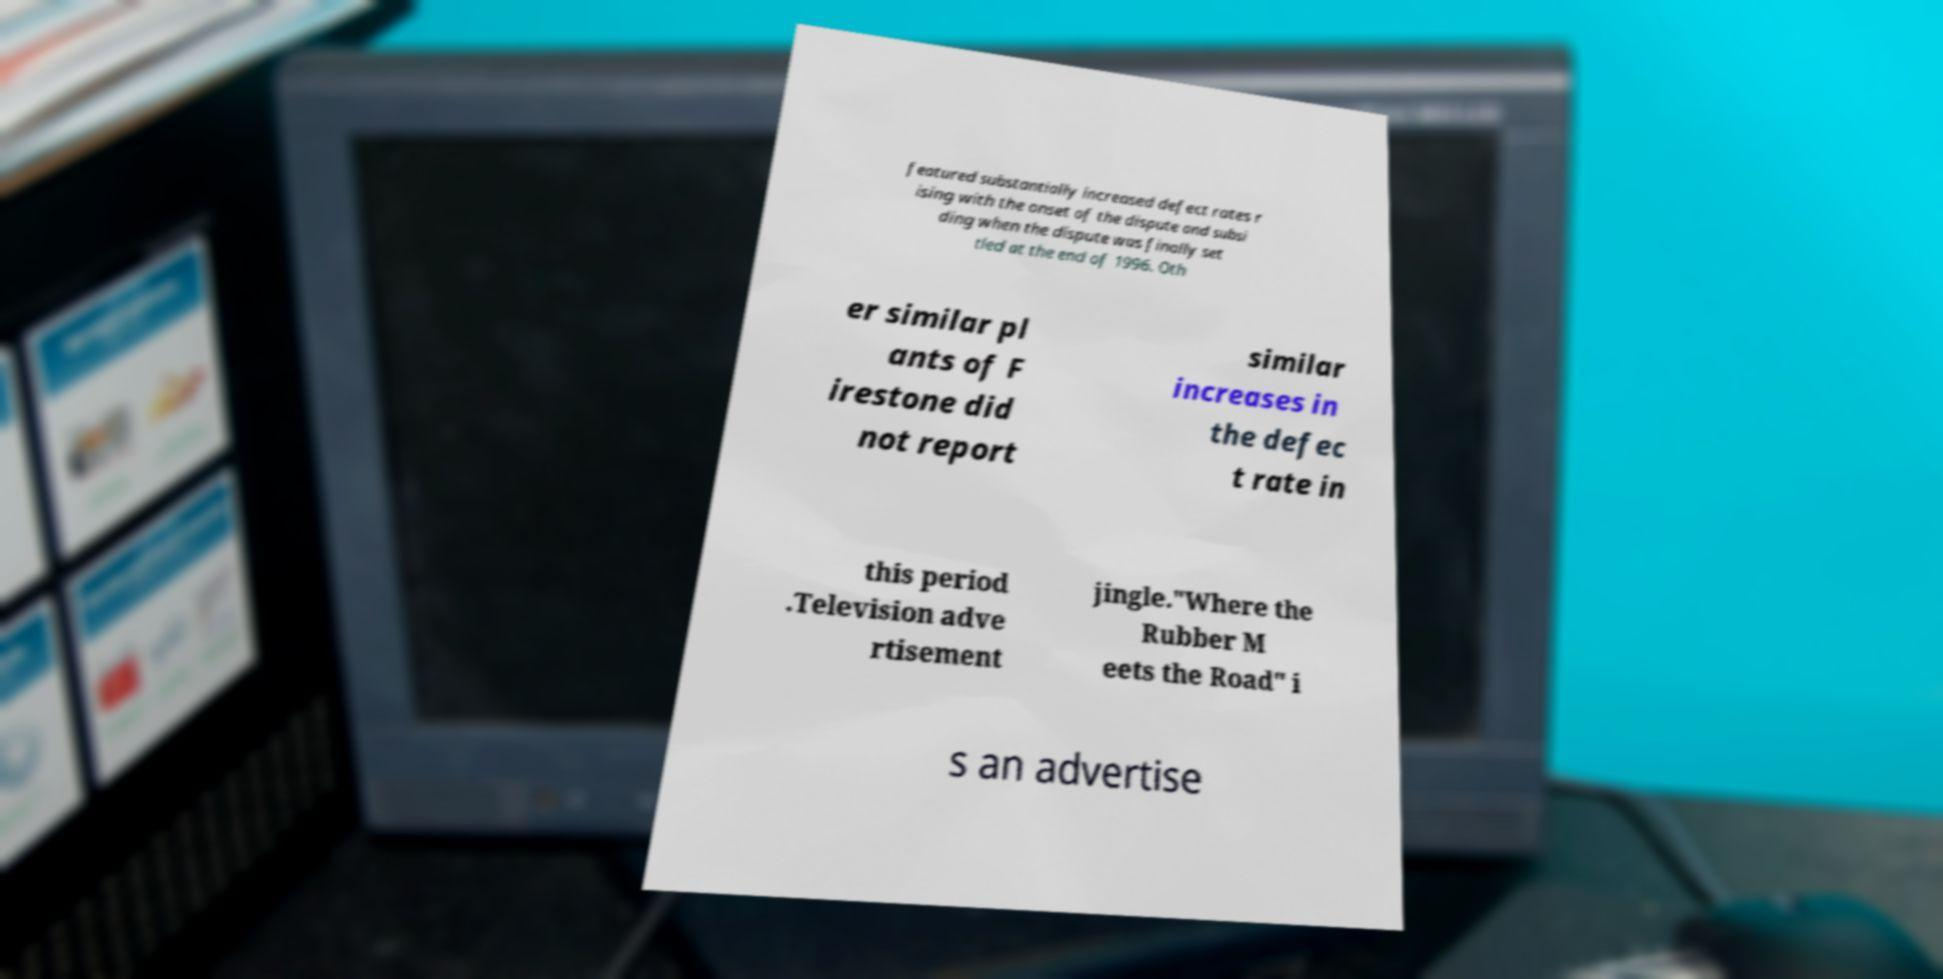I need the written content from this picture converted into text. Can you do that? featured substantially increased defect rates r ising with the onset of the dispute and subsi ding when the dispute was finally set tled at the end of 1996. Oth er similar pl ants of F irestone did not report similar increases in the defec t rate in this period .Television adve rtisement jingle."Where the Rubber M eets the Road" i s an advertise 